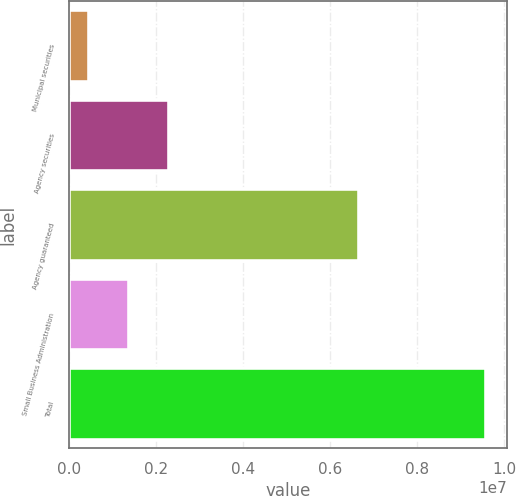Convert chart to OTSL. <chart><loc_0><loc_0><loc_500><loc_500><bar_chart><fcel>Municipal securities<fcel>Agency securities<fcel>Agency guaranteed<fcel>Small Business Administration<fcel>Total<nl><fcel>467056<fcel>2.29072e+06<fcel>6.64925e+06<fcel>1.37889e+06<fcel>9.58536e+06<nl></chart> 